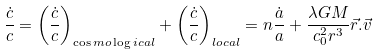Convert formula to latex. <formula><loc_0><loc_0><loc_500><loc_500>\frac { \dot { c } } { c } = \left ( \frac { \dot { c } } { c } \right ) _ { \cos m o \log i c a l } + \left ( \frac { \dot { c } } { c } \right ) _ { l o c a l } = n \frac { \dot { a } } { a } + \frac { \lambda G M } { c _ { 0 } ^ { 2 } r ^ { 3 } } \vec { r } . \vec { v }</formula> 